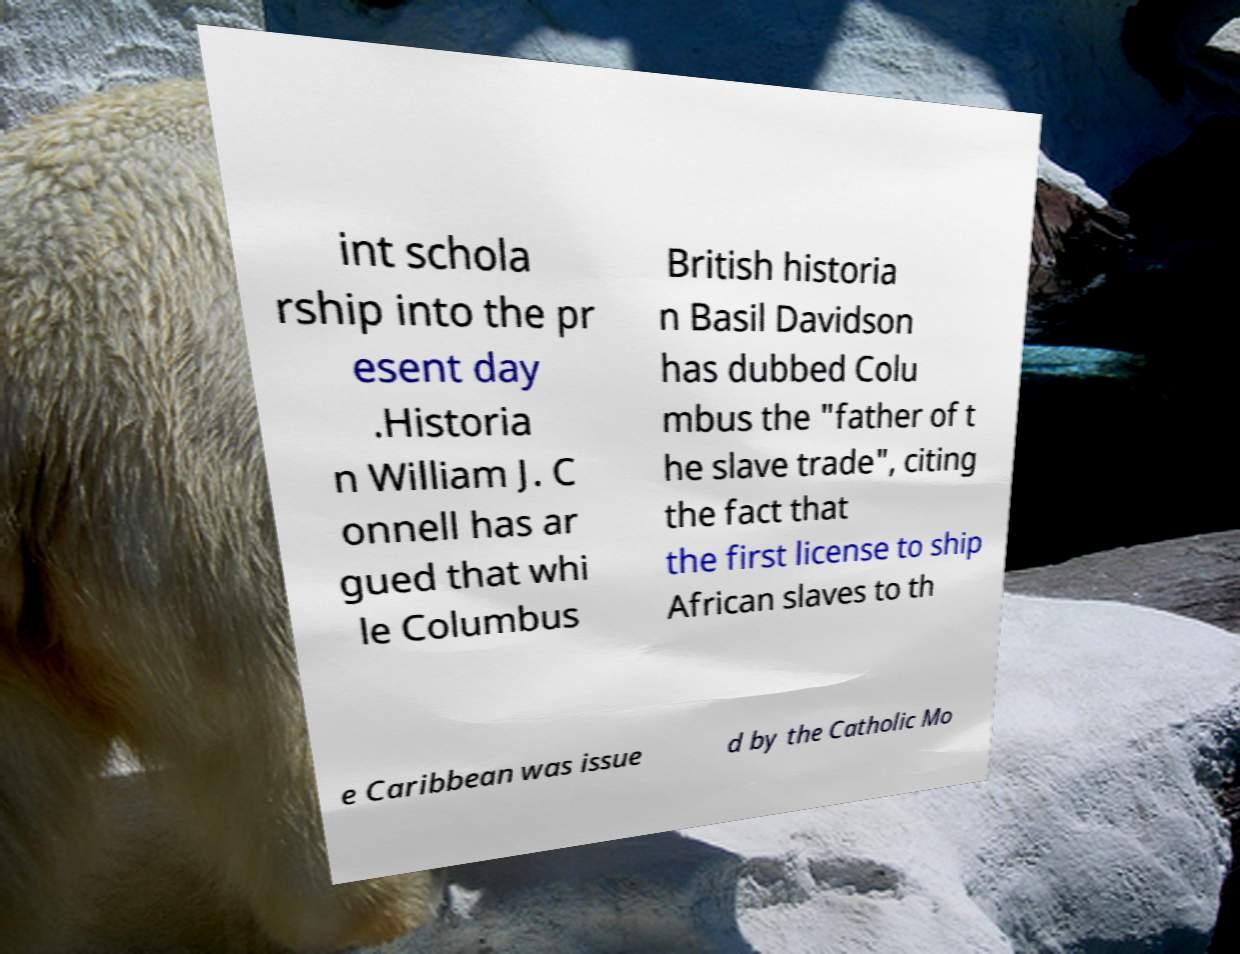I need the written content from this picture converted into text. Can you do that? int schola rship into the pr esent day .Historia n William J. C onnell has ar gued that whi le Columbus British historia n Basil Davidson has dubbed Colu mbus the "father of t he slave trade", citing the fact that the first license to ship African slaves to th e Caribbean was issue d by the Catholic Mo 